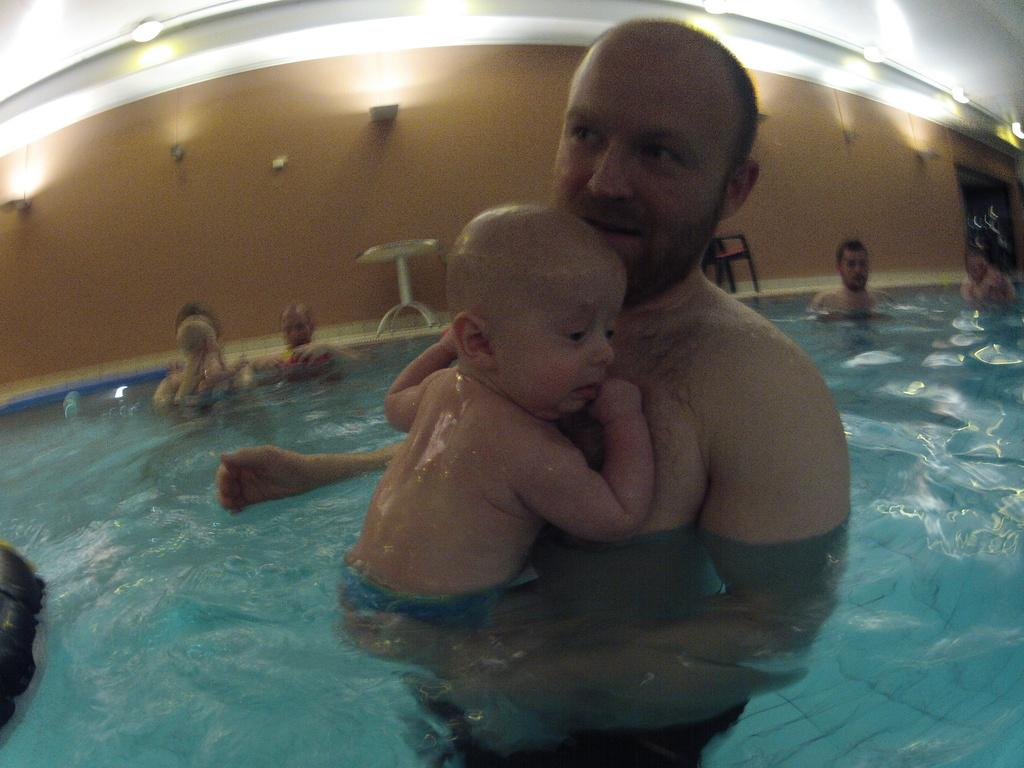What is the main subject of the image? There is a person and a baby in the swimming pool. Can you describe the setting of the image? The image shows a swimming pool with water, and there are persons, a table, a chair, doors, lights, and a wall visible in the background. How many people are in the swimming pool? There are two people in the swimming pool, a person and a baby. What can be seen on the wall in the background? There are lights visible on the wall in the background. How many friends does the baby have in the image? The image does not show any friends; it only shows a person and a baby in the swimming pool. Can you see any wounds on the person in the swimming pool? There is no indication of any wounds on the person in the image. 